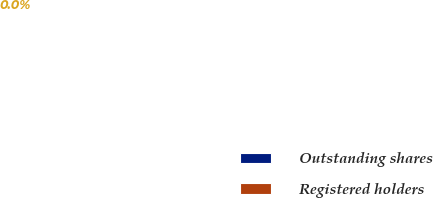Convert chart to OTSL. <chart><loc_0><loc_0><loc_500><loc_500><pie_chart><fcel>Outstanding shares<fcel>Registered holders<nl><fcel>100.0%<fcel>0.0%<nl></chart> 